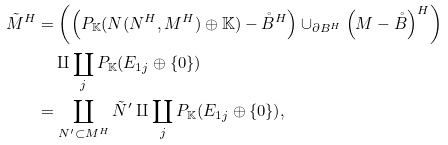Convert formula to latex. <formula><loc_0><loc_0><loc_500><loc_500>\tilde { M } ^ { H } & = \left ( \left ( P _ { \mathbb { K } } ( N ( N ^ { H } , M ^ { H } ) \oplus \mathbb { K } ) - \mathring { B } ^ { H } \right ) \cup _ { \partial B ^ { H } } \left ( M - \mathring { B } \right ) ^ { H } \right ) \\ & \quad \amalg \coprod _ { j } P _ { \mathbb { K } } ( E _ { 1 j } \oplus \{ 0 \} ) \\ & = \coprod _ { N ^ { \prime } \subset M ^ { H } } \tilde { N } ^ { \prime } \amalg \coprod _ { j } P _ { \mathbb { K } } ( E _ { 1 j } \oplus \{ 0 \} ) ,</formula> 